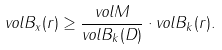Convert formula to latex. <formula><loc_0><loc_0><loc_500><loc_500>v o l B _ { x } ( r ) \geq \frac { v o l M } { v o l B _ { k } ( D ) } \cdot v o l B _ { k } ( r ) .</formula> 